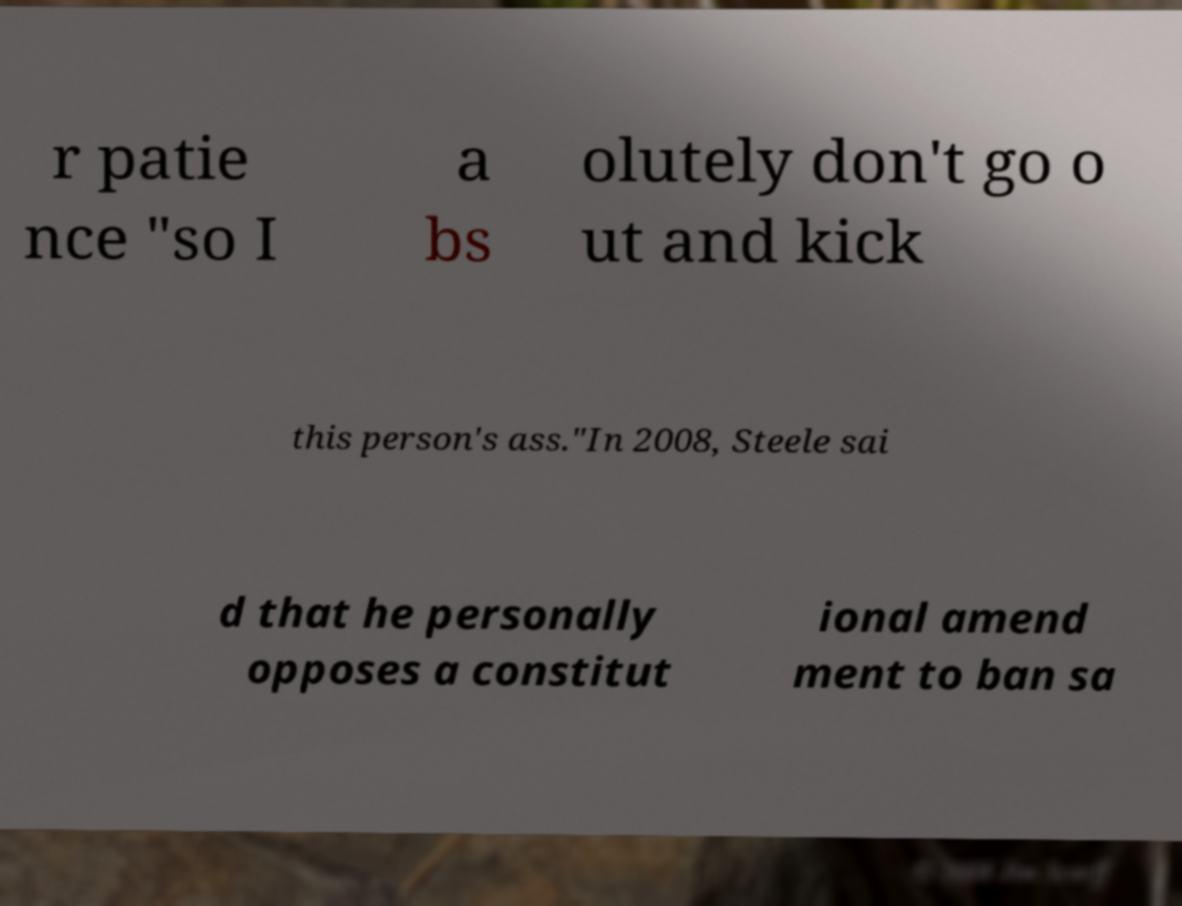I need the written content from this picture converted into text. Can you do that? r patie nce "so I a bs olutely don't go o ut and kick this person's ass."In 2008, Steele sai d that he personally opposes a constitut ional amend ment to ban sa 